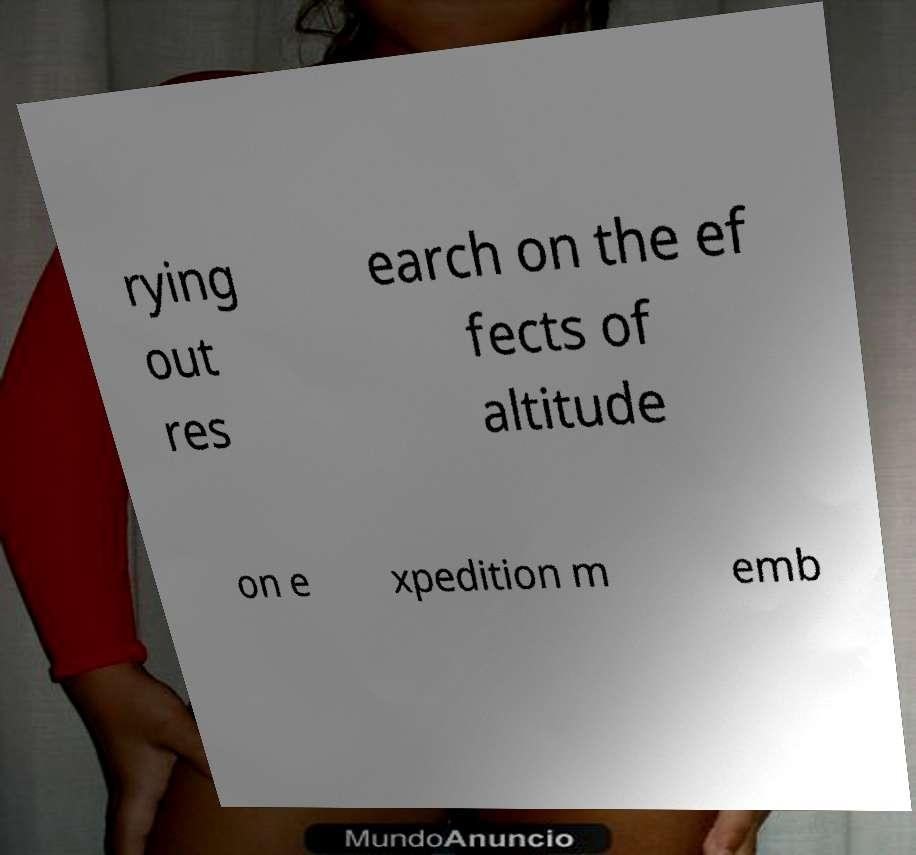Please identify and transcribe the text found in this image. rying out res earch on the ef fects of altitude on e xpedition m emb 